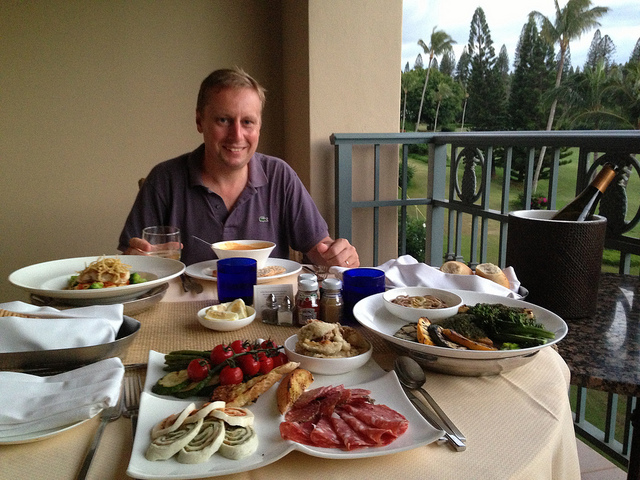How many people are shown at the table? There is one person shown seated at the table, enjoying what appears to be a luxurious assortment of dishes in an outdoor dining setting, with a serene view of greenery in the background. 